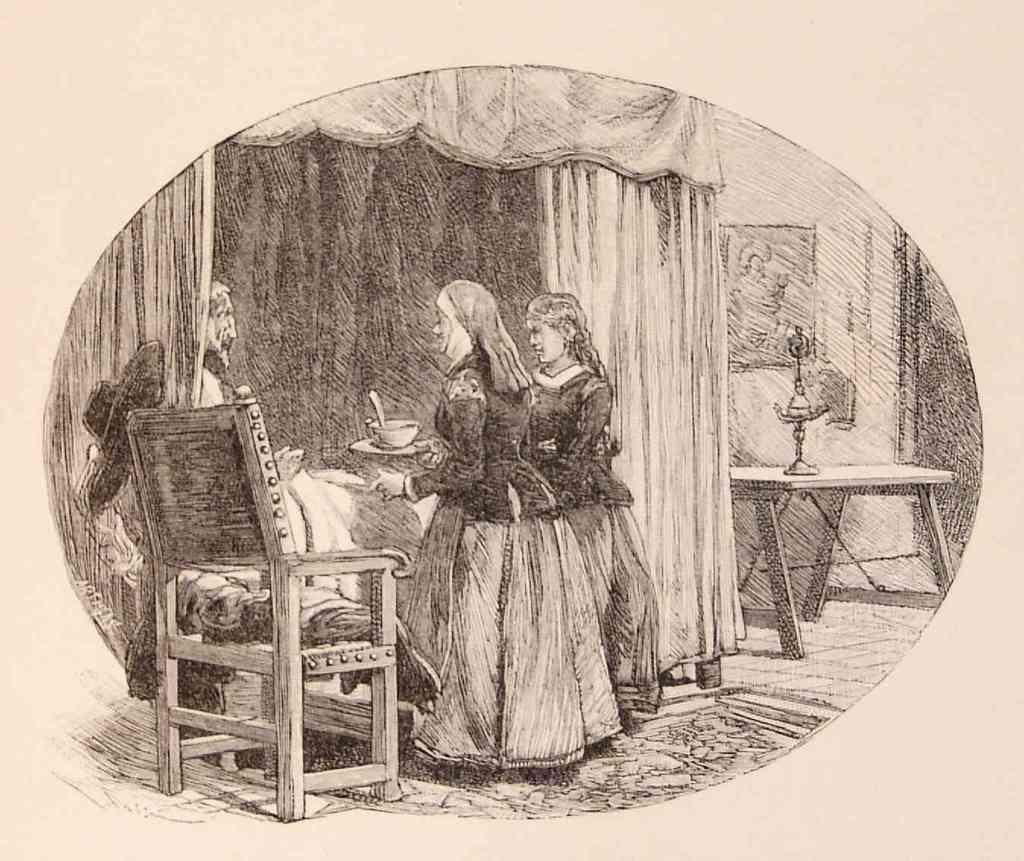What is the main subject of the image? There is a painting in the image. What type of bell can be seen in the painting? There is no bell present in the painting; it is not mentioned in the provided facts. 